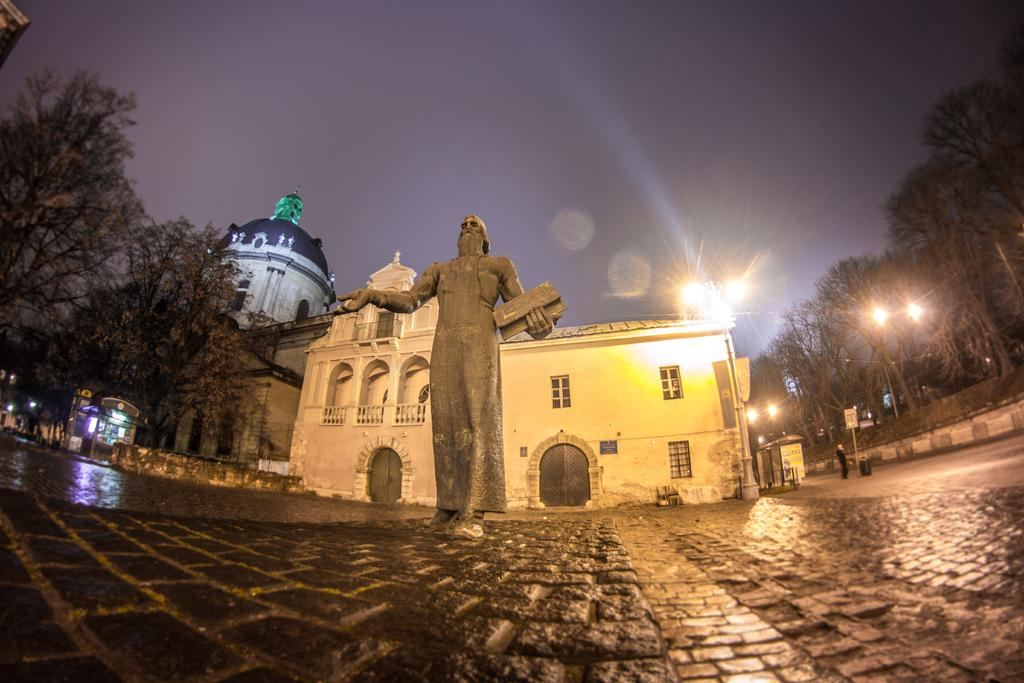What type of surface is visible in the image? There is a pavement in the image. What is located on the pavement? There is a sculpture on the pavement. What can be seen in the distance in the image? There are buildings, trees, and light poles in the background of the image. What letter is being stretched out by the sculpture in the image? There is no letter present in the image, and the sculpture is not stretching out any letters. 